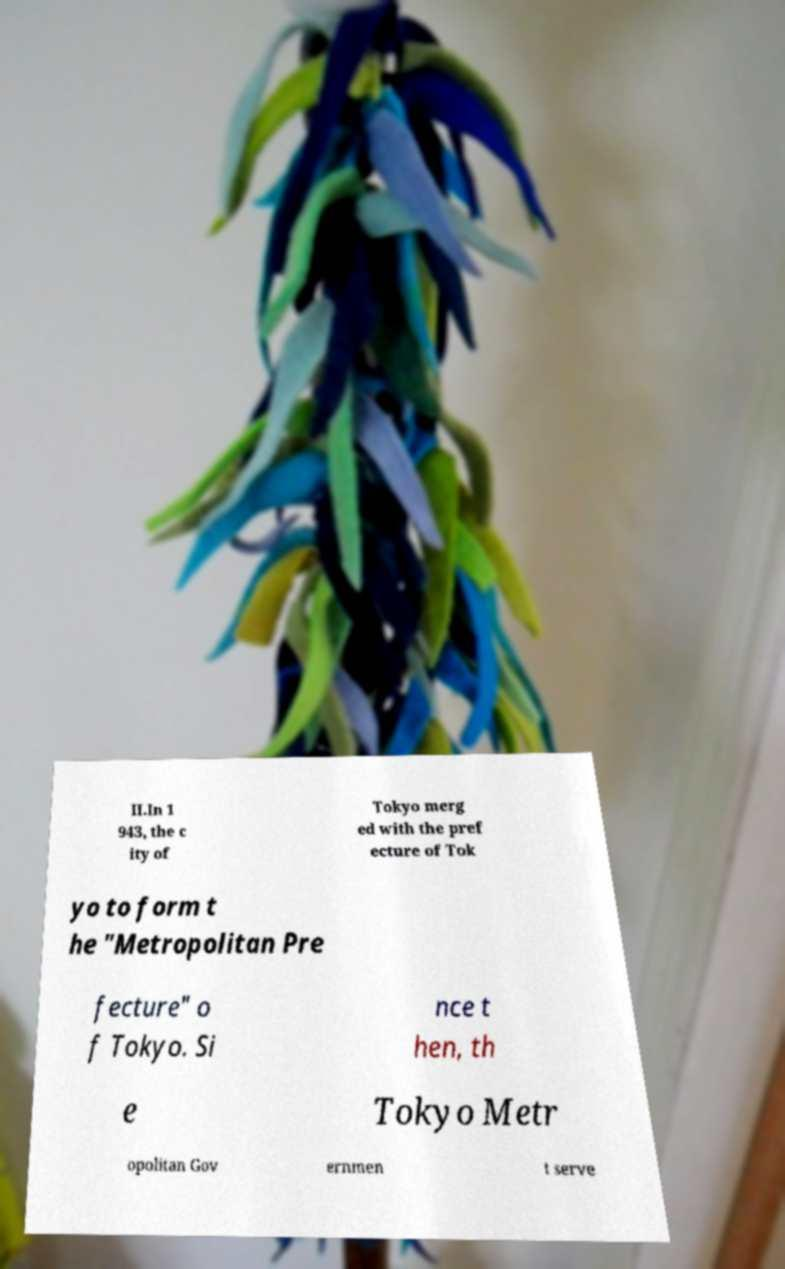Please identify and transcribe the text found in this image. II.In 1 943, the c ity of Tokyo merg ed with the pref ecture of Tok yo to form t he "Metropolitan Pre fecture" o f Tokyo. Si nce t hen, th e Tokyo Metr opolitan Gov ernmen t serve 